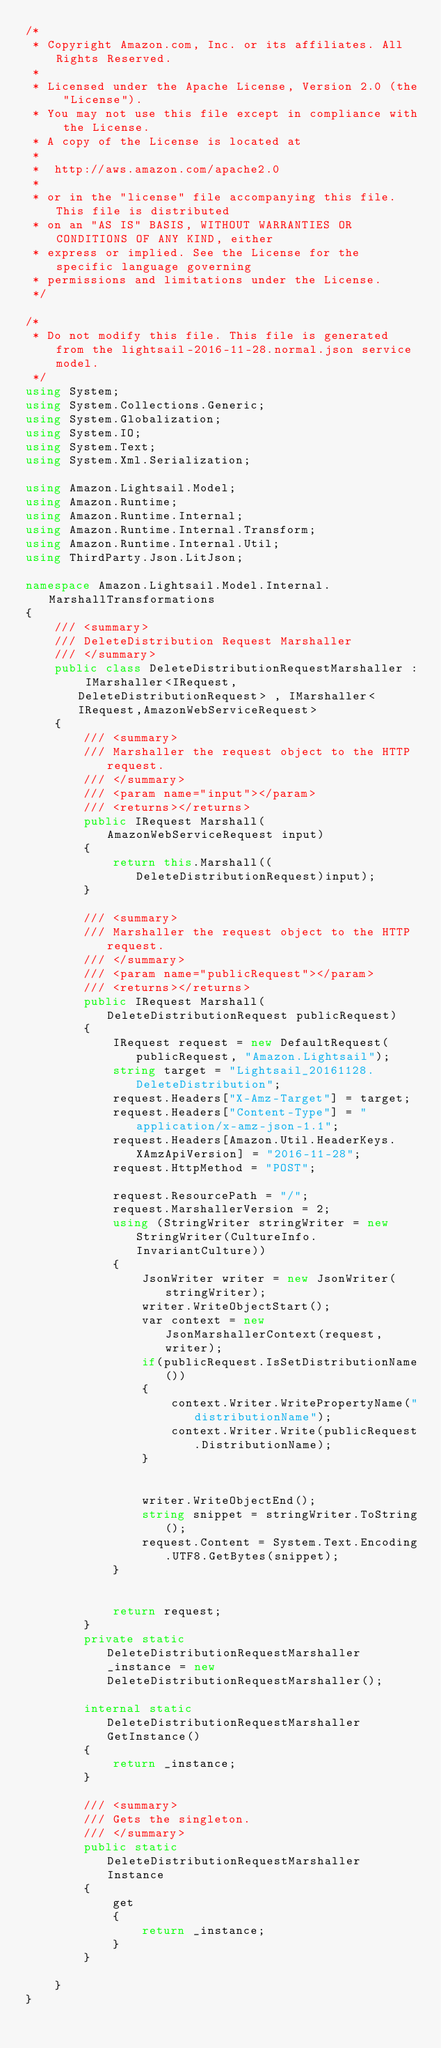Convert code to text. <code><loc_0><loc_0><loc_500><loc_500><_C#_>/*
 * Copyright Amazon.com, Inc. or its affiliates. All Rights Reserved.
 * 
 * Licensed under the Apache License, Version 2.0 (the "License").
 * You may not use this file except in compliance with the License.
 * A copy of the License is located at
 * 
 *  http://aws.amazon.com/apache2.0
 * 
 * or in the "license" file accompanying this file. This file is distributed
 * on an "AS IS" BASIS, WITHOUT WARRANTIES OR CONDITIONS OF ANY KIND, either
 * express or implied. See the License for the specific language governing
 * permissions and limitations under the License.
 */

/*
 * Do not modify this file. This file is generated from the lightsail-2016-11-28.normal.json service model.
 */
using System;
using System.Collections.Generic;
using System.Globalization;
using System.IO;
using System.Text;
using System.Xml.Serialization;

using Amazon.Lightsail.Model;
using Amazon.Runtime;
using Amazon.Runtime.Internal;
using Amazon.Runtime.Internal.Transform;
using Amazon.Runtime.Internal.Util;
using ThirdParty.Json.LitJson;

namespace Amazon.Lightsail.Model.Internal.MarshallTransformations
{
    /// <summary>
    /// DeleteDistribution Request Marshaller
    /// </summary>       
    public class DeleteDistributionRequestMarshaller : IMarshaller<IRequest, DeleteDistributionRequest> , IMarshaller<IRequest,AmazonWebServiceRequest>
    {
        /// <summary>
        /// Marshaller the request object to the HTTP request.
        /// </summary>  
        /// <param name="input"></param>
        /// <returns></returns>
        public IRequest Marshall(AmazonWebServiceRequest input)
        {
            return this.Marshall((DeleteDistributionRequest)input);
        }

        /// <summary>
        /// Marshaller the request object to the HTTP request.
        /// </summary>  
        /// <param name="publicRequest"></param>
        /// <returns></returns>
        public IRequest Marshall(DeleteDistributionRequest publicRequest)
        {
            IRequest request = new DefaultRequest(publicRequest, "Amazon.Lightsail");
            string target = "Lightsail_20161128.DeleteDistribution";
            request.Headers["X-Amz-Target"] = target;
            request.Headers["Content-Type"] = "application/x-amz-json-1.1";
            request.Headers[Amazon.Util.HeaderKeys.XAmzApiVersion] = "2016-11-28";            
            request.HttpMethod = "POST";

            request.ResourcePath = "/";
            request.MarshallerVersion = 2;
            using (StringWriter stringWriter = new StringWriter(CultureInfo.InvariantCulture))
            {
                JsonWriter writer = new JsonWriter(stringWriter);
                writer.WriteObjectStart();
                var context = new JsonMarshallerContext(request, writer);
                if(publicRequest.IsSetDistributionName())
                {
                    context.Writer.WritePropertyName("distributionName");
                    context.Writer.Write(publicRequest.DistributionName);
                }

        
                writer.WriteObjectEnd();
                string snippet = stringWriter.ToString();
                request.Content = System.Text.Encoding.UTF8.GetBytes(snippet);
            }


            return request;
        }
        private static DeleteDistributionRequestMarshaller _instance = new DeleteDistributionRequestMarshaller();        

        internal static DeleteDistributionRequestMarshaller GetInstance()
        {
            return _instance;
        }

        /// <summary>
        /// Gets the singleton.
        /// </summary>  
        public static DeleteDistributionRequestMarshaller Instance
        {
            get
            {
                return _instance;
            }
        }

    }
}</code> 